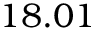<formula> <loc_0><loc_0><loc_500><loc_500>1 8 . 0 1</formula> 